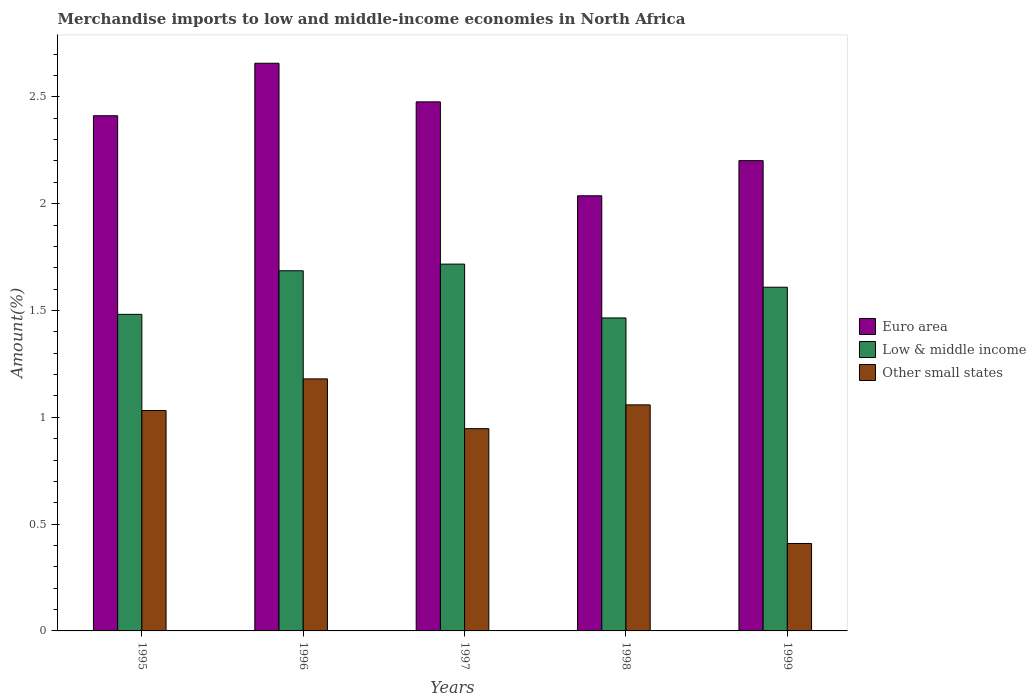How many different coloured bars are there?
Provide a short and direct response. 3. Are the number of bars per tick equal to the number of legend labels?
Your answer should be compact. Yes. Are the number of bars on each tick of the X-axis equal?
Your response must be concise. Yes. What is the label of the 2nd group of bars from the left?
Provide a succinct answer. 1996. In how many cases, is the number of bars for a given year not equal to the number of legend labels?
Your response must be concise. 0. What is the percentage of amount earned from merchandise imports in Low & middle income in 1995?
Keep it short and to the point. 1.48. Across all years, what is the maximum percentage of amount earned from merchandise imports in Low & middle income?
Provide a short and direct response. 1.72. Across all years, what is the minimum percentage of amount earned from merchandise imports in Other small states?
Provide a short and direct response. 0.41. In which year was the percentage of amount earned from merchandise imports in Low & middle income minimum?
Give a very brief answer. 1998. What is the total percentage of amount earned from merchandise imports in Euro area in the graph?
Make the answer very short. 11.78. What is the difference between the percentage of amount earned from merchandise imports in Other small states in 1995 and that in 1999?
Ensure brevity in your answer.  0.62. What is the difference between the percentage of amount earned from merchandise imports in Other small states in 1997 and the percentage of amount earned from merchandise imports in Low & middle income in 1995?
Your answer should be compact. -0.54. What is the average percentage of amount earned from merchandise imports in Euro area per year?
Make the answer very short. 2.36. In the year 1998, what is the difference between the percentage of amount earned from merchandise imports in Low & middle income and percentage of amount earned from merchandise imports in Euro area?
Offer a terse response. -0.57. In how many years, is the percentage of amount earned from merchandise imports in Euro area greater than 0.30000000000000004 %?
Offer a very short reply. 5. What is the ratio of the percentage of amount earned from merchandise imports in Low & middle income in 1997 to that in 1998?
Your answer should be very brief. 1.17. Is the percentage of amount earned from merchandise imports in Low & middle income in 1995 less than that in 1998?
Ensure brevity in your answer.  No. Is the difference between the percentage of amount earned from merchandise imports in Low & middle income in 1995 and 1997 greater than the difference between the percentage of amount earned from merchandise imports in Euro area in 1995 and 1997?
Keep it short and to the point. No. What is the difference between the highest and the second highest percentage of amount earned from merchandise imports in Low & middle income?
Provide a succinct answer. 0.03. What is the difference between the highest and the lowest percentage of amount earned from merchandise imports in Euro area?
Provide a succinct answer. 0.62. In how many years, is the percentage of amount earned from merchandise imports in Other small states greater than the average percentage of amount earned from merchandise imports in Other small states taken over all years?
Provide a short and direct response. 4. Is the sum of the percentage of amount earned from merchandise imports in Euro area in 1996 and 1999 greater than the maximum percentage of amount earned from merchandise imports in Low & middle income across all years?
Your response must be concise. Yes. What does the 3rd bar from the left in 1998 represents?
Provide a short and direct response. Other small states. What does the 2nd bar from the right in 1999 represents?
Your answer should be compact. Low & middle income. Is it the case that in every year, the sum of the percentage of amount earned from merchandise imports in Other small states and percentage of amount earned from merchandise imports in Euro area is greater than the percentage of amount earned from merchandise imports in Low & middle income?
Make the answer very short. Yes. What is the difference between two consecutive major ticks on the Y-axis?
Provide a succinct answer. 0.5. Are the values on the major ticks of Y-axis written in scientific E-notation?
Your response must be concise. No. Does the graph contain grids?
Make the answer very short. No. How many legend labels are there?
Offer a terse response. 3. What is the title of the graph?
Make the answer very short. Merchandise imports to low and middle-income economies in North Africa. What is the label or title of the Y-axis?
Offer a terse response. Amount(%). What is the Amount(%) in Euro area in 1995?
Keep it short and to the point. 2.41. What is the Amount(%) of Low & middle income in 1995?
Give a very brief answer. 1.48. What is the Amount(%) in Other small states in 1995?
Keep it short and to the point. 1.03. What is the Amount(%) of Euro area in 1996?
Ensure brevity in your answer.  2.66. What is the Amount(%) of Low & middle income in 1996?
Give a very brief answer. 1.69. What is the Amount(%) of Other small states in 1996?
Ensure brevity in your answer.  1.18. What is the Amount(%) of Euro area in 1997?
Provide a succinct answer. 2.48. What is the Amount(%) in Low & middle income in 1997?
Offer a very short reply. 1.72. What is the Amount(%) in Other small states in 1997?
Make the answer very short. 0.95. What is the Amount(%) of Euro area in 1998?
Offer a very short reply. 2.04. What is the Amount(%) of Low & middle income in 1998?
Ensure brevity in your answer.  1.47. What is the Amount(%) of Other small states in 1998?
Your answer should be compact. 1.06. What is the Amount(%) of Euro area in 1999?
Provide a succinct answer. 2.2. What is the Amount(%) of Low & middle income in 1999?
Provide a short and direct response. 1.61. What is the Amount(%) in Other small states in 1999?
Your answer should be very brief. 0.41. Across all years, what is the maximum Amount(%) in Euro area?
Your answer should be compact. 2.66. Across all years, what is the maximum Amount(%) of Low & middle income?
Give a very brief answer. 1.72. Across all years, what is the maximum Amount(%) in Other small states?
Give a very brief answer. 1.18. Across all years, what is the minimum Amount(%) in Euro area?
Offer a terse response. 2.04. Across all years, what is the minimum Amount(%) of Low & middle income?
Your answer should be very brief. 1.47. Across all years, what is the minimum Amount(%) of Other small states?
Your answer should be very brief. 0.41. What is the total Amount(%) of Euro area in the graph?
Offer a terse response. 11.78. What is the total Amount(%) in Low & middle income in the graph?
Give a very brief answer. 7.96. What is the total Amount(%) of Other small states in the graph?
Keep it short and to the point. 4.63. What is the difference between the Amount(%) of Euro area in 1995 and that in 1996?
Ensure brevity in your answer.  -0.25. What is the difference between the Amount(%) in Low & middle income in 1995 and that in 1996?
Your answer should be compact. -0.2. What is the difference between the Amount(%) in Other small states in 1995 and that in 1996?
Offer a very short reply. -0.15. What is the difference between the Amount(%) in Euro area in 1995 and that in 1997?
Make the answer very short. -0.06. What is the difference between the Amount(%) of Low & middle income in 1995 and that in 1997?
Give a very brief answer. -0.24. What is the difference between the Amount(%) in Other small states in 1995 and that in 1997?
Provide a succinct answer. 0.09. What is the difference between the Amount(%) in Euro area in 1995 and that in 1998?
Offer a very short reply. 0.37. What is the difference between the Amount(%) in Low & middle income in 1995 and that in 1998?
Provide a short and direct response. 0.02. What is the difference between the Amount(%) of Other small states in 1995 and that in 1998?
Make the answer very short. -0.03. What is the difference between the Amount(%) in Euro area in 1995 and that in 1999?
Keep it short and to the point. 0.21. What is the difference between the Amount(%) in Low & middle income in 1995 and that in 1999?
Keep it short and to the point. -0.13. What is the difference between the Amount(%) of Other small states in 1995 and that in 1999?
Give a very brief answer. 0.62. What is the difference between the Amount(%) in Euro area in 1996 and that in 1997?
Provide a short and direct response. 0.18. What is the difference between the Amount(%) in Low & middle income in 1996 and that in 1997?
Ensure brevity in your answer.  -0.03. What is the difference between the Amount(%) in Other small states in 1996 and that in 1997?
Keep it short and to the point. 0.23. What is the difference between the Amount(%) of Euro area in 1996 and that in 1998?
Offer a very short reply. 0.62. What is the difference between the Amount(%) of Low & middle income in 1996 and that in 1998?
Provide a succinct answer. 0.22. What is the difference between the Amount(%) of Other small states in 1996 and that in 1998?
Your answer should be very brief. 0.12. What is the difference between the Amount(%) of Euro area in 1996 and that in 1999?
Provide a succinct answer. 0.46. What is the difference between the Amount(%) of Low & middle income in 1996 and that in 1999?
Ensure brevity in your answer.  0.08. What is the difference between the Amount(%) in Other small states in 1996 and that in 1999?
Provide a short and direct response. 0.77. What is the difference between the Amount(%) of Euro area in 1997 and that in 1998?
Ensure brevity in your answer.  0.44. What is the difference between the Amount(%) of Low & middle income in 1997 and that in 1998?
Offer a terse response. 0.25. What is the difference between the Amount(%) in Other small states in 1997 and that in 1998?
Provide a short and direct response. -0.11. What is the difference between the Amount(%) in Euro area in 1997 and that in 1999?
Offer a very short reply. 0.28. What is the difference between the Amount(%) of Low & middle income in 1997 and that in 1999?
Give a very brief answer. 0.11. What is the difference between the Amount(%) of Other small states in 1997 and that in 1999?
Provide a short and direct response. 0.54. What is the difference between the Amount(%) in Euro area in 1998 and that in 1999?
Offer a terse response. -0.16. What is the difference between the Amount(%) of Low & middle income in 1998 and that in 1999?
Ensure brevity in your answer.  -0.14. What is the difference between the Amount(%) of Other small states in 1998 and that in 1999?
Your answer should be compact. 0.65. What is the difference between the Amount(%) of Euro area in 1995 and the Amount(%) of Low & middle income in 1996?
Your response must be concise. 0.73. What is the difference between the Amount(%) in Euro area in 1995 and the Amount(%) in Other small states in 1996?
Your answer should be very brief. 1.23. What is the difference between the Amount(%) in Low & middle income in 1995 and the Amount(%) in Other small states in 1996?
Your answer should be compact. 0.3. What is the difference between the Amount(%) of Euro area in 1995 and the Amount(%) of Low & middle income in 1997?
Give a very brief answer. 0.69. What is the difference between the Amount(%) in Euro area in 1995 and the Amount(%) in Other small states in 1997?
Your answer should be very brief. 1.46. What is the difference between the Amount(%) of Low & middle income in 1995 and the Amount(%) of Other small states in 1997?
Offer a very short reply. 0.54. What is the difference between the Amount(%) in Euro area in 1995 and the Amount(%) in Low & middle income in 1998?
Give a very brief answer. 0.95. What is the difference between the Amount(%) in Euro area in 1995 and the Amount(%) in Other small states in 1998?
Keep it short and to the point. 1.35. What is the difference between the Amount(%) of Low & middle income in 1995 and the Amount(%) of Other small states in 1998?
Your answer should be very brief. 0.42. What is the difference between the Amount(%) of Euro area in 1995 and the Amount(%) of Low & middle income in 1999?
Make the answer very short. 0.8. What is the difference between the Amount(%) in Euro area in 1995 and the Amount(%) in Other small states in 1999?
Make the answer very short. 2. What is the difference between the Amount(%) of Low & middle income in 1995 and the Amount(%) of Other small states in 1999?
Provide a short and direct response. 1.07. What is the difference between the Amount(%) in Euro area in 1996 and the Amount(%) in Low & middle income in 1997?
Offer a terse response. 0.94. What is the difference between the Amount(%) of Euro area in 1996 and the Amount(%) of Other small states in 1997?
Your answer should be compact. 1.71. What is the difference between the Amount(%) of Low & middle income in 1996 and the Amount(%) of Other small states in 1997?
Keep it short and to the point. 0.74. What is the difference between the Amount(%) of Euro area in 1996 and the Amount(%) of Low & middle income in 1998?
Ensure brevity in your answer.  1.19. What is the difference between the Amount(%) of Euro area in 1996 and the Amount(%) of Other small states in 1998?
Give a very brief answer. 1.6. What is the difference between the Amount(%) in Low & middle income in 1996 and the Amount(%) in Other small states in 1998?
Your answer should be very brief. 0.63. What is the difference between the Amount(%) of Euro area in 1996 and the Amount(%) of Low & middle income in 1999?
Ensure brevity in your answer.  1.05. What is the difference between the Amount(%) in Euro area in 1996 and the Amount(%) in Other small states in 1999?
Offer a very short reply. 2.25. What is the difference between the Amount(%) of Low & middle income in 1996 and the Amount(%) of Other small states in 1999?
Keep it short and to the point. 1.28. What is the difference between the Amount(%) of Euro area in 1997 and the Amount(%) of Low & middle income in 1998?
Keep it short and to the point. 1.01. What is the difference between the Amount(%) in Euro area in 1997 and the Amount(%) in Other small states in 1998?
Offer a terse response. 1.42. What is the difference between the Amount(%) of Low & middle income in 1997 and the Amount(%) of Other small states in 1998?
Provide a succinct answer. 0.66. What is the difference between the Amount(%) of Euro area in 1997 and the Amount(%) of Low & middle income in 1999?
Offer a very short reply. 0.87. What is the difference between the Amount(%) of Euro area in 1997 and the Amount(%) of Other small states in 1999?
Your answer should be very brief. 2.07. What is the difference between the Amount(%) in Low & middle income in 1997 and the Amount(%) in Other small states in 1999?
Give a very brief answer. 1.31. What is the difference between the Amount(%) in Euro area in 1998 and the Amount(%) in Low & middle income in 1999?
Provide a short and direct response. 0.43. What is the difference between the Amount(%) in Euro area in 1998 and the Amount(%) in Other small states in 1999?
Your response must be concise. 1.63. What is the difference between the Amount(%) of Low & middle income in 1998 and the Amount(%) of Other small states in 1999?
Give a very brief answer. 1.06. What is the average Amount(%) of Euro area per year?
Your answer should be very brief. 2.36. What is the average Amount(%) in Low & middle income per year?
Your answer should be very brief. 1.59. What is the average Amount(%) in Other small states per year?
Your answer should be compact. 0.93. In the year 1995, what is the difference between the Amount(%) in Euro area and Amount(%) in Low & middle income?
Offer a terse response. 0.93. In the year 1995, what is the difference between the Amount(%) in Euro area and Amount(%) in Other small states?
Provide a succinct answer. 1.38. In the year 1995, what is the difference between the Amount(%) in Low & middle income and Amount(%) in Other small states?
Your response must be concise. 0.45. In the year 1996, what is the difference between the Amount(%) of Euro area and Amount(%) of Low & middle income?
Your response must be concise. 0.97. In the year 1996, what is the difference between the Amount(%) in Euro area and Amount(%) in Other small states?
Your response must be concise. 1.48. In the year 1996, what is the difference between the Amount(%) of Low & middle income and Amount(%) of Other small states?
Ensure brevity in your answer.  0.51. In the year 1997, what is the difference between the Amount(%) in Euro area and Amount(%) in Low & middle income?
Give a very brief answer. 0.76. In the year 1997, what is the difference between the Amount(%) of Euro area and Amount(%) of Other small states?
Make the answer very short. 1.53. In the year 1997, what is the difference between the Amount(%) of Low & middle income and Amount(%) of Other small states?
Give a very brief answer. 0.77. In the year 1998, what is the difference between the Amount(%) in Euro area and Amount(%) in Low & middle income?
Give a very brief answer. 0.57. In the year 1998, what is the difference between the Amount(%) in Euro area and Amount(%) in Other small states?
Provide a succinct answer. 0.98. In the year 1998, what is the difference between the Amount(%) of Low & middle income and Amount(%) of Other small states?
Give a very brief answer. 0.41. In the year 1999, what is the difference between the Amount(%) of Euro area and Amount(%) of Low & middle income?
Your response must be concise. 0.59. In the year 1999, what is the difference between the Amount(%) in Euro area and Amount(%) in Other small states?
Your response must be concise. 1.79. In the year 1999, what is the difference between the Amount(%) of Low & middle income and Amount(%) of Other small states?
Your answer should be very brief. 1.2. What is the ratio of the Amount(%) in Euro area in 1995 to that in 1996?
Provide a succinct answer. 0.91. What is the ratio of the Amount(%) of Low & middle income in 1995 to that in 1996?
Provide a short and direct response. 0.88. What is the ratio of the Amount(%) in Other small states in 1995 to that in 1996?
Make the answer very short. 0.87. What is the ratio of the Amount(%) in Euro area in 1995 to that in 1997?
Keep it short and to the point. 0.97. What is the ratio of the Amount(%) of Low & middle income in 1995 to that in 1997?
Ensure brevity in your answer.  0.86. What is the ratio of the Amount(%) in Other small states in 1995 to that in 1997?
Your answer should be very brief. 1.09. What is the ratio of the Amount(%) in Euro area in 1995 to that in 1998?
Offer a very short reply. 1.18. What is the ratio of the Amount(%) in Low & middle income in 1995 to that in 1998?
Offer a very short reply. 1.01. What is the ratio of the Amount(%) of Other small states in 1995 to that in 1998?
Give a very brief answer. 0.98. What is the ratio of the Amount(%) of Euro area in 1995 to that in 1999?
Keep it short and to the point. 1.1. What is the ratio of the Amount(%) in Low & middle income in 1995 to that in 1999?
Provide a succinct answer. 0.92. What is the ratio of the Amount(%) in Other small states in 1995 to that in 1999?
Keep it short and to the point. 2.52. What is the ratio of the Amount(%) in Euro area in 1996 to that in 1997?
Your response must be concise. 1.07. What is the ratio of the Amount(%) of Low & middle income in 1996 to that in 1997?
Offer a terse response. 0.98. What is the ratio of the Amount(%) in Other small states in 1996 to that in 1997?
Keep it short and to the point. 1.25. What is the ratio of the Amount(%) in Euro area in 1996 to that in 1998?
Offer a terse response. 1.3. What is the ratio of the Amount(%) in Low & middle income in 1996 to that in 1998?
Your answer should be very brief. 1.15. What is the ratio of the Amount(%) in Other small states in 1996 to that in 1998?
Your answer should be very brief. 1.11. What is the ratio of the Amount(%) in Euro area in 1996 to that in 1999?
Make the answer very short. 1.21. What is the ratio of the Amount(%) of Low & middle income in 1996 to that in 1999?
Keep it short and to the point. 1.05. What is the ratio of the Amount(%) of Other small states in 1996 to that in 1999?
Provide a succinct answer. 2.88. What is the ratio of the Amount(%) of Euro area in 1997 to that in 1998?
Ensure brevity in your answer.  1.22. What is the ratio of the Amount(%) in Low & middle income in 1997 to that in 1998?
Keep it short and to the point. 1.17. What is the ratio of the Amount(%) in Other small states in 1997 to that in 1998?
Offer a very short reply. 0.89. What is the ratio of the Amount(%) of Euro area in 1997 to that in 1999?
Make the answer very short. 1.12. What is the ratio of the Amount(%) in Low & middle income in 1997 to that in 1999?
Your answer should be compact. 1.07. What is the ratio of the Amount(%) of Other small states in 1997 to that in 1999?
Provide a succinct answer. 2.31. What is the ratio of the Amount(%) of Euro area in 1998 to that in 1999?
Your answer should be compact. 0.93. What is the ratio of the Amount(%) of Low & middle income in 1998 to that in 1999?
Make the answer very short. 0.91. What is the ratio of the Amount(%) in Other small states in 1998 to that in 1999?
Your answer should be compact. 2.59. What is the difference between the highest and the second highest Amount(%) in Euro area?
Your answer should be very brief. 0.18. What is the difference between the highest and the second highest Amount(%) of Low & middle income?
Make the answer very short. 0.03. What is the difference between the highest and the second highest Amount(%) of Other small states?
Keep it short and to the point. 0.12. What is the difference between the highest and the lowest Amount(%) in Euro area?
Make the answer very short. 0.62. What is the difference between the highest and the lowest Amount(%) of Low & middle income?
Your answer should be very brief. 0.25. What is the difference between the highest and the lowest Amount(%) of Other small states?
Provide a short and direct response. 0.77. 